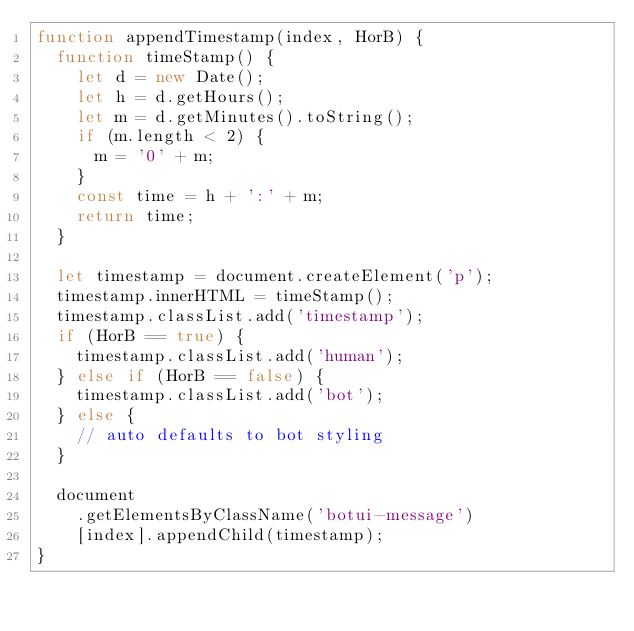<code> <loc_0><loc_0><loc_500><loc_500><_JavaScript_>function appendTimestamp(index, HorB) {
  function timeStamp() {
    let d = new Date();
    let h = d.getHours();
    let m = d.getMinutes().toString();
    if (m.length < 2) {
      m = '0' + m;
    }
    const time = h + ':' + m;
    return time;
  }

  let timestamp = document.createElement('p');
  timestamp.innerHTML = timeStamp();
  timestamp.classList.add('timestamp');
  if (HorB == true) {
    timestamp.classList.add('human');
  } else if (HorB == false) {
    timestamp.classList.add('bot');
  } else {
    // auto defaults to bot styling
  }

  document
    .getElementsByClassName('botui-message')
    [index].appendChild(timestamp);
}
</code> 